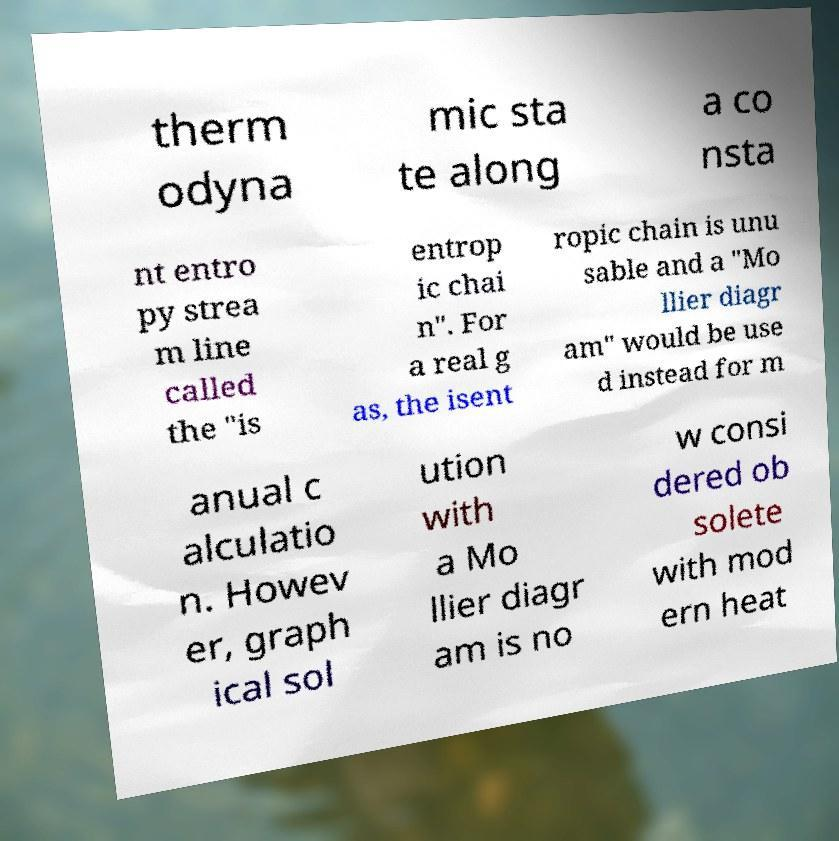Could you assist in decoding the text presented in this image and type it out clearly? therm odyna mic sta te along a co nsta nt entro py strea m line called the "is entrop ic chai n". For a real g as, the isent ropic chain is unu sable and a "Mo llier diagr am" would be use d instead for m anual c alculatio n. Howev er, graph ical sol ution with a Mo llier diagr am is no w consi dered ob solete with mod ern heat 